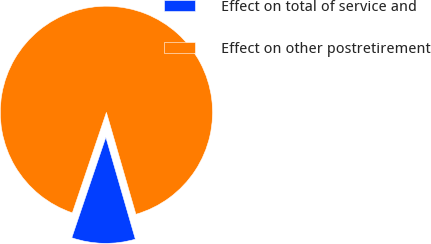Convert chart. <chart><loc_0><loc_0><loc_500><loc_500><pie_chart><fcel>Effect on total of service and<fcel>Effect on other postretirement<nl><fcel>9.68%<fcel>90.32%<nl></chart> 